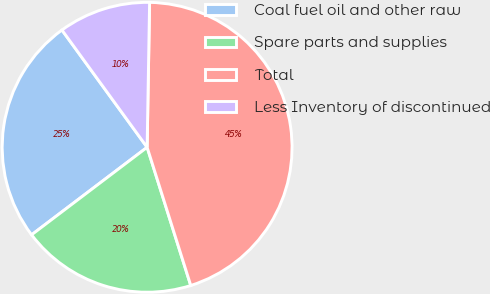Convert chart. <chart><loc_0><loc_0><loc_500><loc_500><pie_chart><fcel>Coal fuel oil and other raw<fcel>Spare parts and supplies<fcel>Total<fcel>Less Inventory of discontinued<nl><fcel>25.32%<fcel>19.55%<fcel>44.86%<fcel>10.27%<nl></chart> 